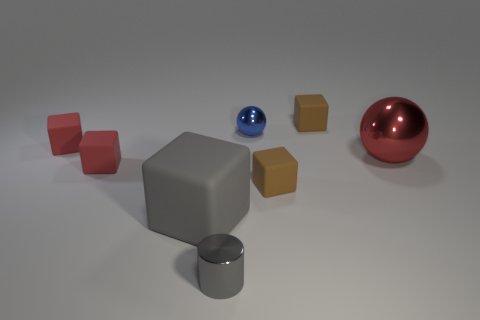Subtract all tiny red matte cubes. How many cubes are left? 3 Add 1 blue objects. How many objects exist? 9 Subtract all gray blocks. How many blocks are left? 4 Subtract all cylinders. How many objects are left? 7 Add 5 gray blocks. How many gray blocks exist? 6 Subtract 1 gray cylinders. How many objects are left? 7 Subtract 3 blocks. How many blocks are left? 2 Subtract all red balls. Subtract all purple blocks. How many balls are left? 1 Subtract all red cylinders. How many green cubes are left? 0 Subtract all large spheres. Subtract all yellow cylinders. How many objects are left? 7 